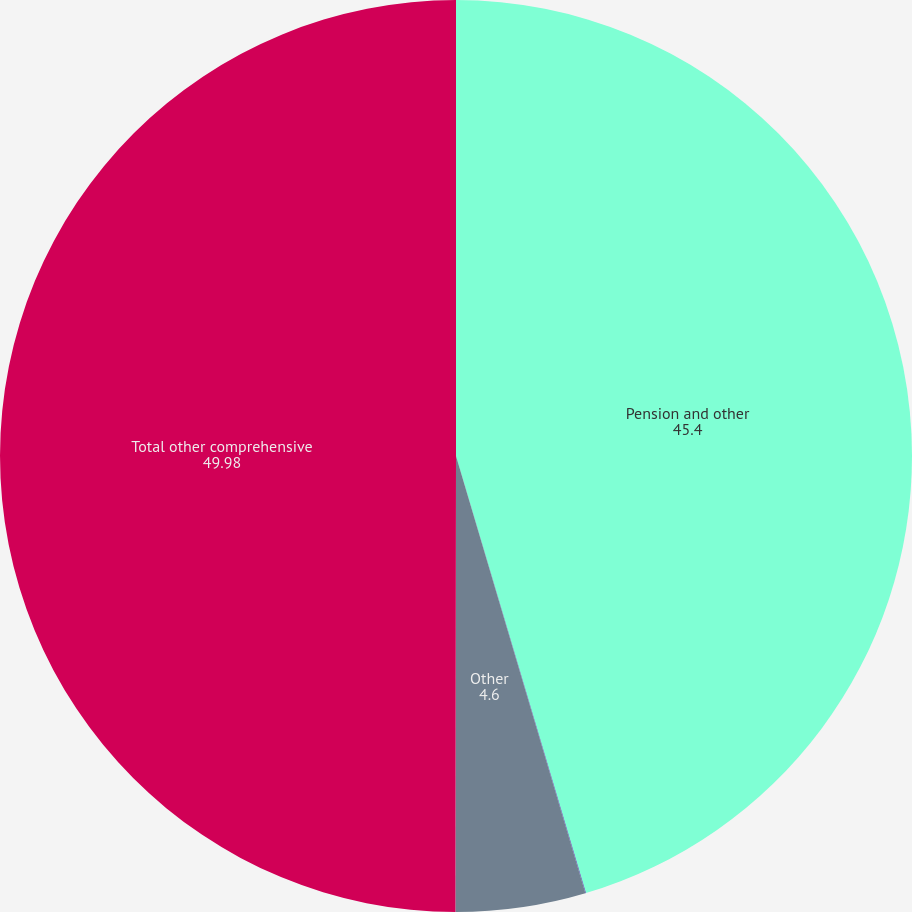Convert chart. <chart><loc_0><loc_0><loc_500><loc_500><pie_chart><fcel>Pension and other<fcel>Changes in fair value of cash<fcel>Other<fcel>Total other comprehensive<nl><fcel>45.4%<fcel>0.02%<fcel>4.6%<fcel>49.98%<nl></chart> 